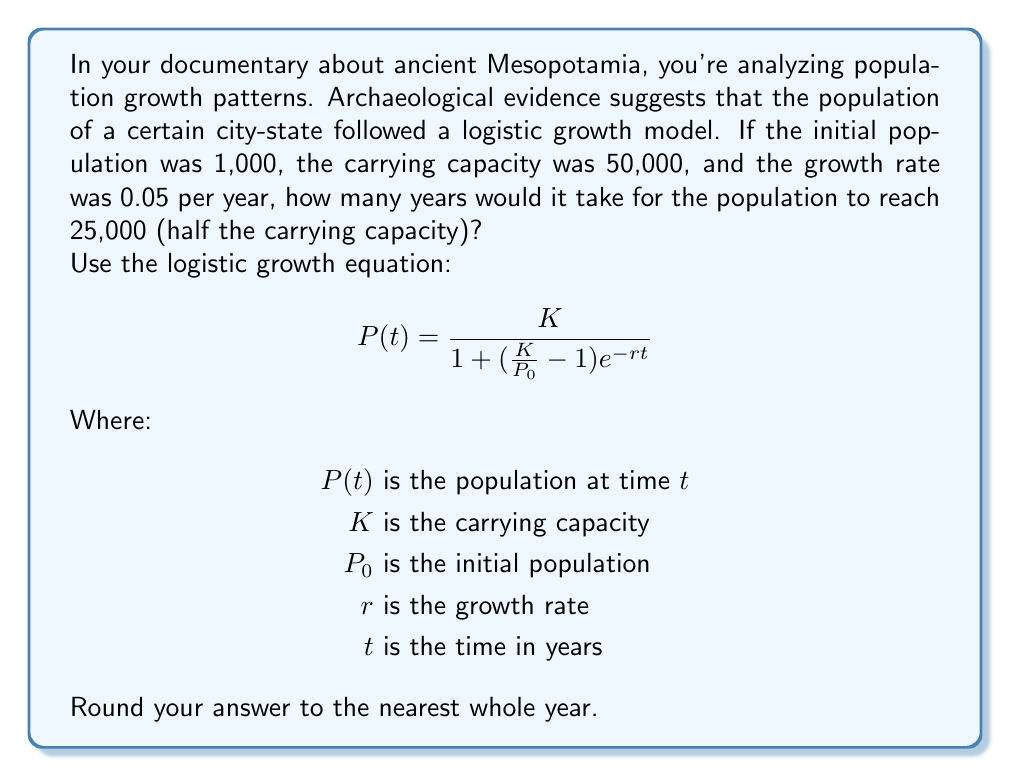Can you answer this question? To solve this problem, we'll use the logistic growth equation and solve for $t$:

1) We know:
   $P(t) = 25,000$ (target population)
   $K = 50,000$ (carrying capacity)
   $P_0 = 1,000$ (initial population)
   $r = 0.05$ (growth rate)

2) Substitute these values into the equation:

   $$25,000 = \frac{50,000}{1 + (\frac{50,000}{1,000} - 1)e^{-0.05t}}$$

3) Simplify:
   $$25,000 = \frac{50,000}{1 + 49e^{-0.05t}}$$

4) Multiply both sides by the denominator:
   $$25,000(1 + 49e^{-0.05t}) = 50,000$$

5) Distribute on the left side:
   $$25,000 + 1,225,000e^{-0.05t} = 50,000$$

6) Subtract 25,000 from both sides:
   $$1,225,000e^{-0.05t} = 25,000$$

7) Divide both sides by 1,225,000:
   $$e^{-0.05t} = \frac{1}{49}$$

8) Take the natural log of both sides:
   $$-0.05t = \ln(\frac{1}{49})$$

9) Divide both sides by -0.05:
   $$t = \frac{\ln(49)}{0.05}$$

10) Calculate the result:
    $$t \approx 77.96$$

11) Round to the nearest whole year:
    $t = 78$ years
Answer: 78 years 